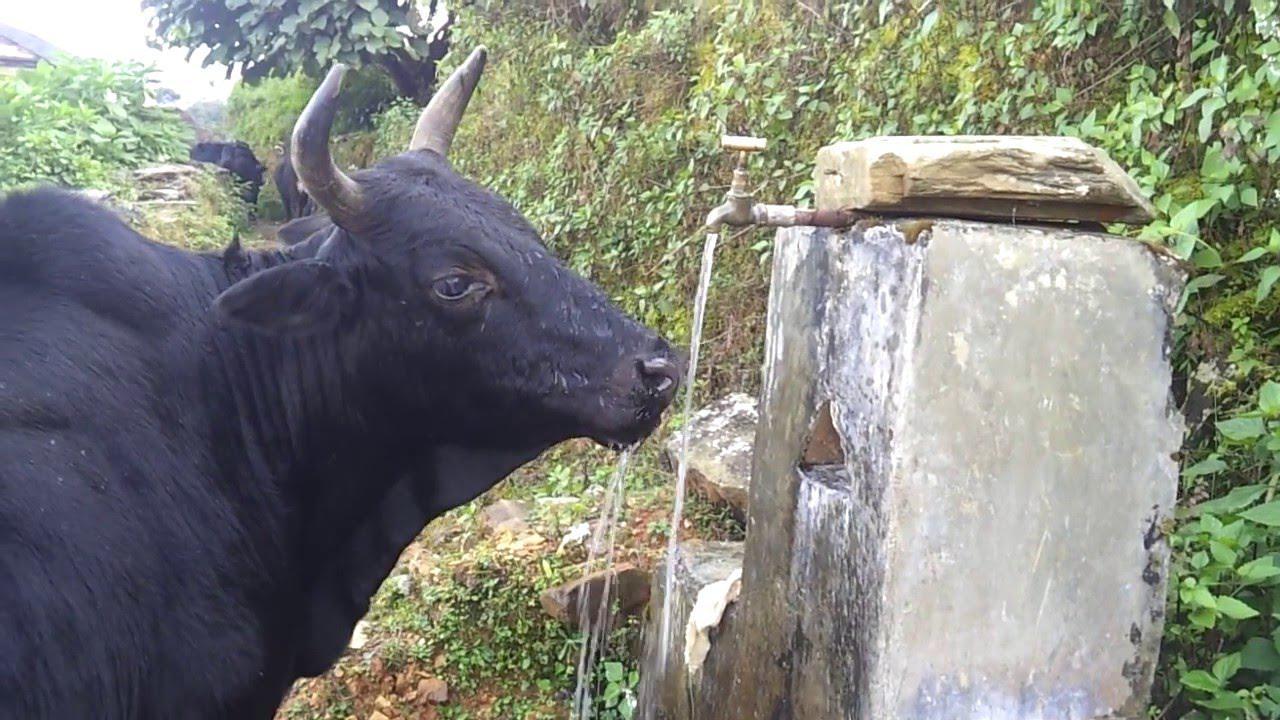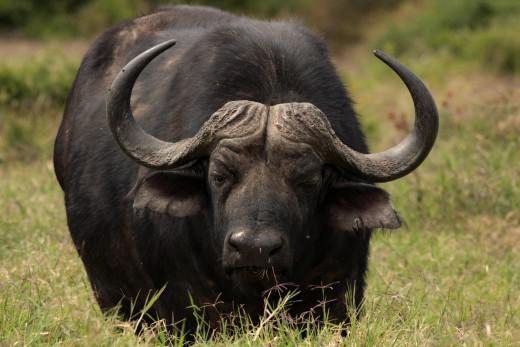The first image is the image on the left, the second image is the image on the right. Given the left and right images, does the statement "The animal in the image on the right is standing in side profile with its head turned toward the camera." hold true? Answer yes or no. No. 